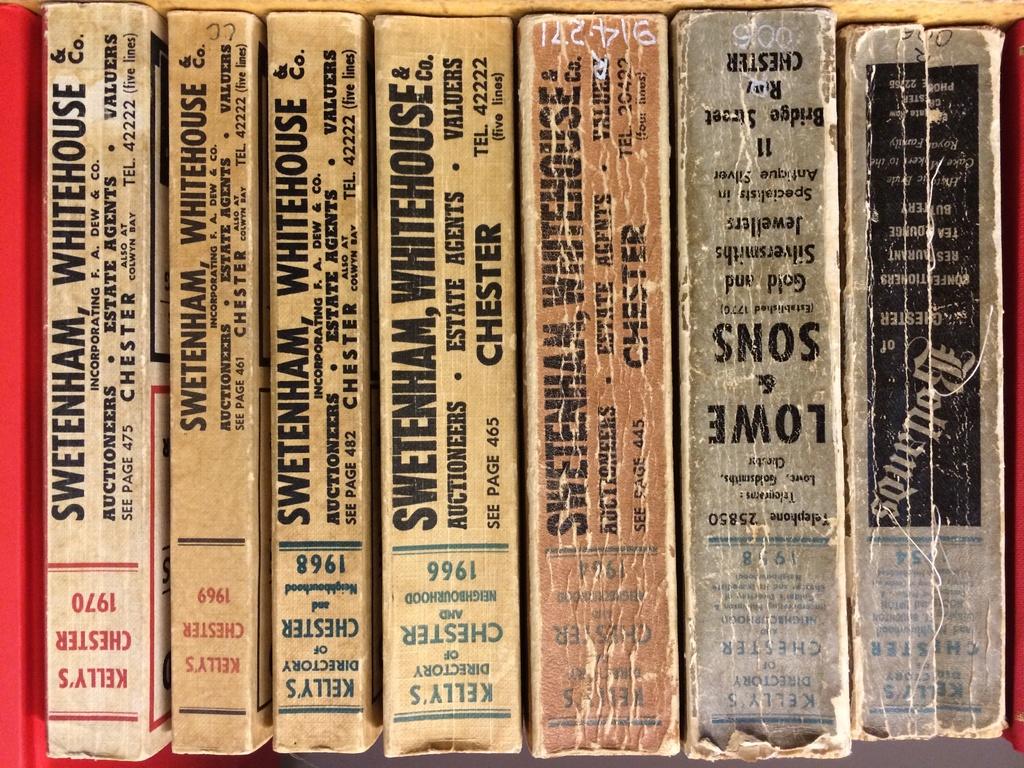What is the latest year shown?
Your answer should be very brief. 1970. What is the title of the last book on the left?
Your answer should be compact. Kelly's chester 1970. 